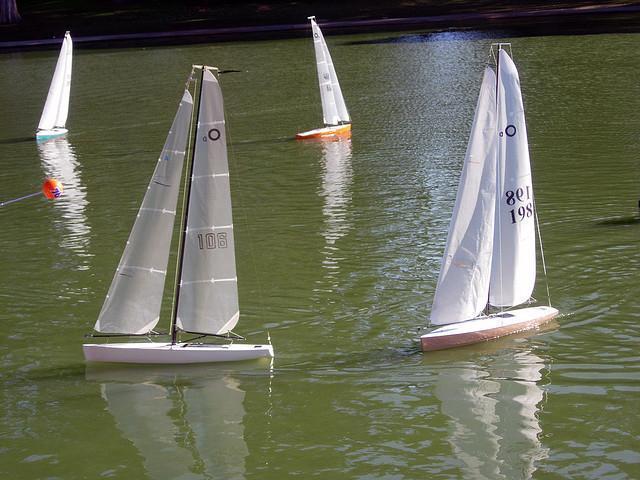How many sailboats are in this scene?
Give a very brief answer. 4. How many boats are visible?
Give a very brief answer. 4. 